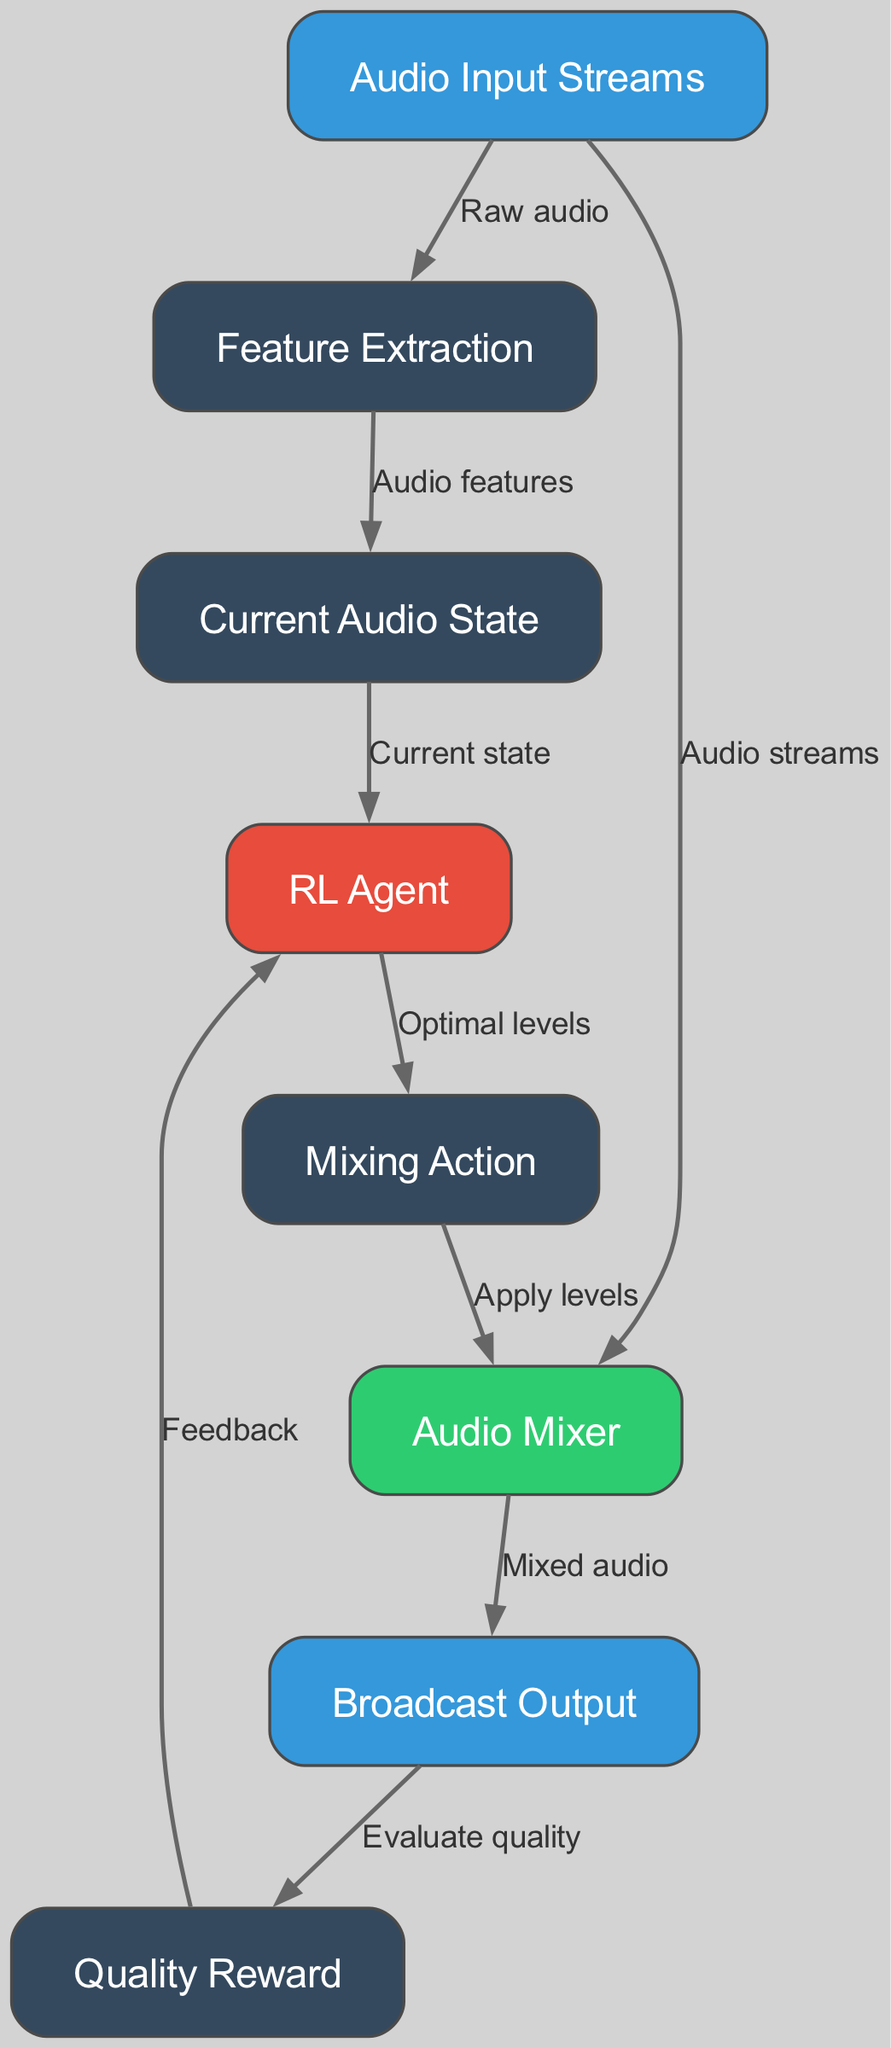What is the first node in the diagram? The diagram starts with the "Audio Input Streams" node, which represents the initial input for the audio mixing process.
Answer: Audio Input Streams How many nodes are present in the diagram? Counting all the nodes listed in the data, there are eight distinct nodes described in the diagram: Audio Input Streams, Feature Extraction, Current Audio State, RL Agent, Mixing Action, Audio Mixer, Broadcast Output, and Quality Reward.
Answer: 8 What is the action taken by the RL Agent? The RL Agent determines the "Optimal levels" for mixing audio based on the current audio state and feedback.
Answer: Optimal levels What is the feedback loop in this diagram? The feedback loop consists of evaluating the quality from the Broadcast Output, which gives a Quality Reward that is sent back to the RL Agent as feedback to optimize its future mixing actions.
Answer: Quality Reward Which node is responsible for applying the levels determined by the RL Agent? The node responsible for applying the levels is the "Audio Mixer," as it receives the Mixing Action from the RL Agent and combines the input streams accordingly.
Answer: Audio Mixer What type of input is processed in the Feature Extraction node? The Feature Extraction node processes "Audio features" that are derived from the raw audio input streams, transforming the data into a format suitable for state evaluation.
Answer: Audio features How is the system evaluated for quality? Quality evaluation is performed in the node labeled "Quality Reward," which assesses the output signal from the Audio Mixer and sends feedback back to the RL Agent.
Answer: Evaluate quality What is the final output of the system? The final output produced by the system after mixing the audio streams is called "Broadcast Output," which represents the mixed audio ready for broadcasting.
Answer: Broadcast Output 